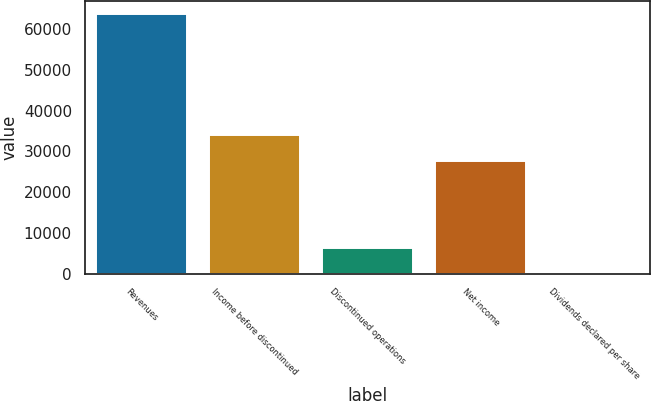<chart> <loc_0><loc_0><loc_500><loc_500><bar_chart><fcel>Revenues<fcel>Income before discontinued<fcel>Discontinued operations<fcel>Net income<fcel>Dividends declared per share<nl><fcel>63800<fcel>33953<fcel>6380.32<fcel>27573<fcel>0.36<nl></chart> 